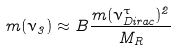Convert formula to latex. <formula><loc_0><loc_0><loc_500><loc_500>m ( \nu _ { 3 } ) \approx B \frac { m ( \nu _ { D i r a c } ^ { \tau } ) ^ { 2 } } { M _ { R } }</formula> 